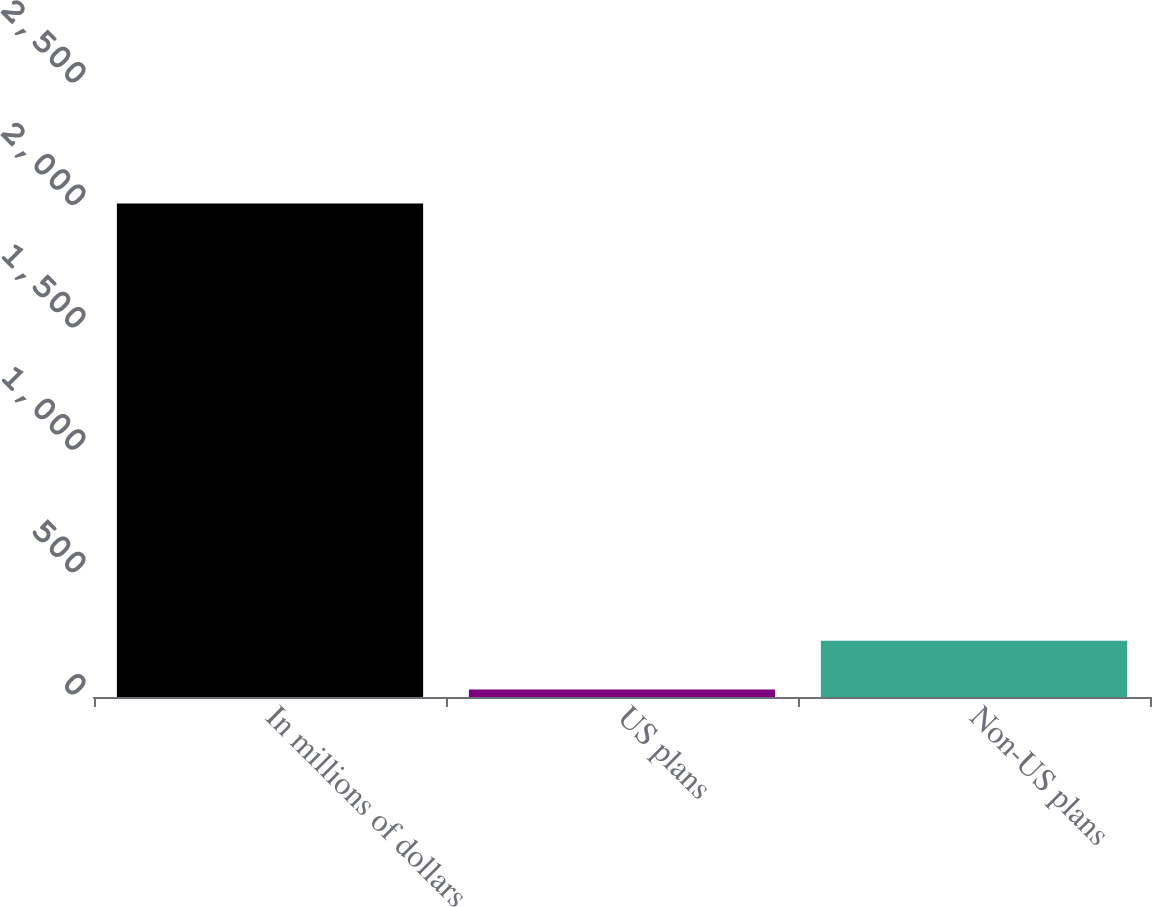<chart> <loc_0><loc_0><loc_500><loc_500><bar_chart><fcel>In millions of dollars<fcel>US plans<fcel>Non-US plans<nl><fcel>2016<fcel>31<fcel>229.5<nl></chart> 